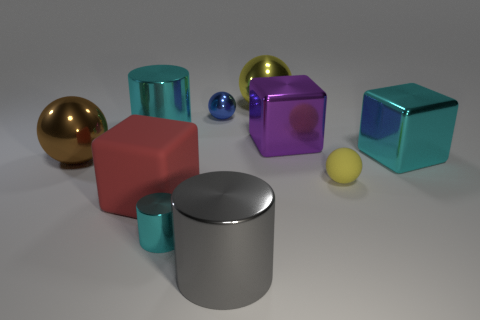Is the size of the cyan cylinder that is in front of the red block the same as the big brown ball? no 